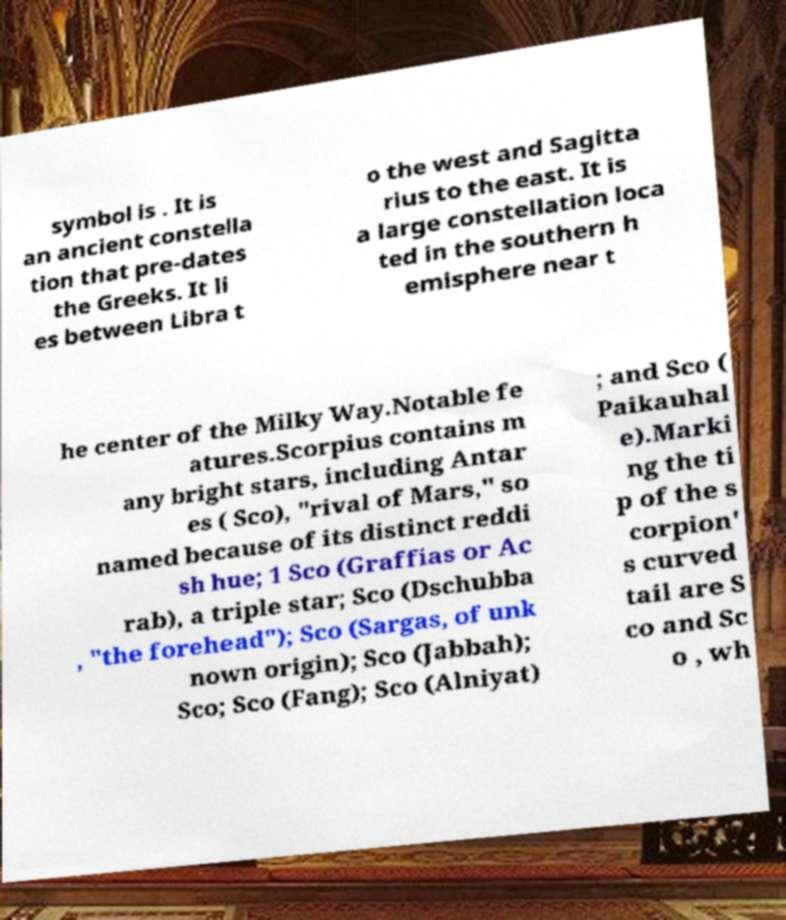For documentation purposes, I need the text within this image transcribed. Could you provide that? symbol is . It is an ancient constella tion that pre-dates the Greeks. It li es between Libra t o the west and Sagitta rius to the east. It is a large constellation loca ted in the southern h emisphere near t he center of the Milky Way.Notable fe atures.Scorpius contains m any bright stars, including Antar es ( Sco), "rival of Mars," so named because of its distinct reddi sh hue; 1 Sco (Graffias or Ac rab), a triple star; Sco (Dschubba , "the forehead"); Sco (Sargas, of unk nown origin); Sco (Jabbah); Sco; Sco (Fang); Sco (Alniyat) ; and Sco ( Paikauhal e).Marki ng the ti p of the s corpion' s curved tail are S co and Sc o , wh 